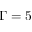Convert formula to latex. <formula><loc_0><loc_0><loc_500><loc_500>\Gamma = 5</formula> 